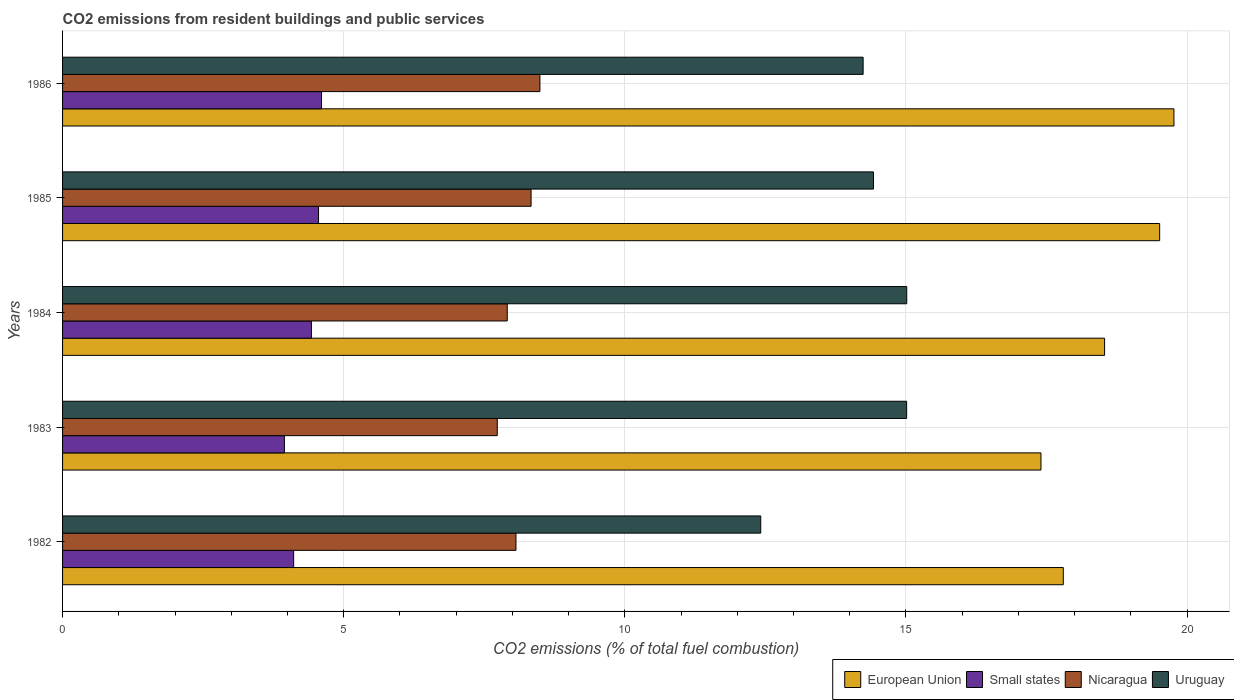How many different coloured bars are there?
Ensure brevity in your answer.  4. Are the number of bars per tick equal to the number of legend labels?
Offer a terse response. Yes. How many bars are there on the 1st tick from the bottom?
Your answer should be compact. 4. What is the total CO2 emitted in Small states in 1984?
Give a very brief answer. 4.43. Across all years, what is the maximum total CO2 emitted in Small states?
Keep it short and to the point. 4.61. Across all years, what is the minimum total CO2 emitted in Uruguay?
Keep it short and to the point. 12.42. In which year was the total CO2 emitted in Uruguay maximum?
Your response must be concise. 1984. In which year was the total CO2 emitted in Small states minimum?
Offer a terse response. 1983. What is the total total CO2 emitted in Uruguay in the graph?
Your response must be concise. 71.11. What is the difference between the total CO2 emitted in Uruguay in 1983 and that in 1984?
Offer a terse response. -0. What is the difference between the total CO2 emitted in Small states in 1985 and the total CO2 emitted in Uruguay in 1986?
Your answer should be very brief. -9.69. What is the average total CO2 emitted in Small states per year?
Your response must be concise. 4.33. In the year 1984, what is the difference between the total CO2 emitted in Small states and total CO2 emitted in European Union?
Ensure brevity in your answer.  -14.11. What is the ratio of the total CO2 emitted in Nicaragua in 1983 to that in 1986?
Provide a succinct answer. 0.91. Is the total CO2 emitted in Uruguay in 1984 less than that in 1985?
Your answer should be compact. No. Is the difference between the total CO2 emitted in Small states in 1982 and 1986 greater than the difference between the total CO2 emitted in European Union in 1982 and 1986?
Offer a very short reply. Yes. What is the difference between the highest and the second highest total CO2 emitted in Nicaragua?
Ensure brevity in your answer.  0.16. What is the difference between the highest and the lowest total CO2 emitted in European Union?
Your answer should be very brief. 2.37. Is the sum of the total CO2 emitted in Nicaragua in 1982 and 1984 greater than the maximum total CO2 emitted in Uruguay across all years?
Ensure brevity in your answer.  Yes. Is it the case that in every year, the sum of the total CO2 emitted in Nicaragua and total CO2 emitted in Uruguay is greater than the sum of total CO2 emitted in Small states and total CO2 emitted in European Union?
Offer a terse response. No. What does the 3rd bar from the top in 1986 represents?
Provide a succinct answer. Small states. What does the 2nd bar from the bottom in 1985 represents?
Your response must be concise. Small states. How many bars are there?
Your answer should be compact. 20. Does the graph contain any zero values?
Give a very brief answer. No. Where does the legend appear in the graph?
Provide a short and direct response. Bottom right. What is the title of the graph?
Ensure brevity in your answer.  CO2 emissions from resident buildings and public services. What is the label or title of the X-axis?
Keep it short and to the point. CO2 emissions (% of total fuel combustion). What is the CO2 emissions (% of total fuel combustion) of European Union in 1982?
Your response must be concise. 17.8. What is the CO2 emissions (% of total fuel combustion) of Small states in 1982?
Keep it short and to the point. 4.11. What is the CO2 emissions (% of total fuel combustion) of Nicaragua in 1982?
Provide a succinct answer. 8.06. What is the CO2 emissions (% of total fuel combustion) of Uruguay in 1982?
Offer a terse response. 12.42. What is the CO2 emissions (% of total fuel combustion) of European Union in 1983?
Your response must be concise. 17.4. What is the CO2 emissions (% of total fuel combustion) in Small states in 1983?
Offer a terse response. 3.95. What is the CO2 emissions (% of total fuel combustion) of Nicaragua in 1983?
Your answer should be very brief. 7.73. What is the CO2 emissions (% of total fuel combustion) in Uruguay in 1983?
Your answer should be very brief. 15.01. What is the CO2 emissions (% of total fuel combustion) in European Union in 1984?
Your response must be concise. 18.53. What is the CO2 emissions (% of total fuel combustion) in Small states in 1984?
Your response must be concise. 4.43. What is the CO2 emissions (% of total fuel combustion) of Nicaragua in 1984?
Ensure brevity in your answer.  7.91. What is the CO2 emissions (% of total fuel combustion) of Uruguay in 1984?
Make the answer very short. 15.02. What is the CO2 emissions (% of total fuel combustion) of European Union in 1985?
Your answer should be very brief. 19.51. What is the CO2 emissions (% of total fuel combustion) in Small states in 1985?
Your answer should be very brief. 4.55. What is the CO2 emissions (% of total fuel combustion) of Nicaragua in 1985?
Offer a very short reply. 8.33. What is the CO2 emissions (% of total fuel combustion) in Uruguay in 1985?
Your answer should be very brief. 14.42. What is the CO2 emissions (% of total fuel combustion) of European Union in 1986?
Offer a very short reply. 19.77. What is the CO2 emissions (% of total fuel combustion) in Small states in 1986?
Your answer should be very brief. 4.61. What is the CO2 emissions (% of total fuel combustion) in Nicaragua in 1986?
Provide a short and direct response. 8.49. What is the CO2 emissions (% of total fuel combustion) in Uruguay in 1986?
Provide a succinct answer. 14.24. Across all years, what is the maximum CO2 emissions (% of total fuel combustion) of European Union?
Keep it short and to the point. 19.77. Across all years, what is the maximum CO2 emissions (% of total fuel combustion) in Small states?
Give a very brief answer. 4.61. Across all years, what is the maximum CO2 emissions (% of total fuel combustion) in Nicaragua?
Offer a terse response. 8.49. Across all years, what is the maximum CO2 emissions (% of total fuel combustion) in Uruguay?
Keep it short and to the point. 15.02. Across all years, what is the minimum CO2 emissions (% of total fuel combustion) in European Union?
Offer a very short reply. 17.4. Across all years, what is the minimum CO2 emissions (% of total fuel combustion) of Small states?
Provide a succinct answer. 3.95. Across all years, what is the minimum CO2 emissions (% of total fuel combustion) in Nicaragua?
Ensure brevity in your answer.  7.73. Across all years, what is the minimum CO2 emissions (% of total fuel combustion) of Uruguay?
Offer a very short reply. 12.42. What is the total CO2 emissions (% of total fuel combustion) in European Union in the graph?
Ensure brevity in your answer.  93.02. What is the total CO2 emissions (% of total fuel combustion) of Small states in the graph?
Offer a terse response. 21.64. What is the total CO2 emissions (% of total fuel combustion) of Nicaragua in the graph?
Keep it short and to the point. 40.53. What is the total CO2 emissions (% of total fuel combustion) of Uruguay in the graph?
Your response must be concise. 71.11. What is the difference between the CO2 emissions (% of total fuel combustion) in European Union in 1982 and that in 1983?
Keep it short and to the point. 0.4. What is the difference between the CO2 emissions (% of total fuel combustion) in Small states in 1982 and that in 1983?
Offer a terse response. 0.16. What is the difference between the CO2 emissions (% of total fuel combustion) of Nicaragua in 1982 and that in 1983?
Offer a very short reply. 0.33. What is the difference between the CO2 emissions (% of total fuel combustion) in Uruguay in 1982 and that in 1983?
Give a very brief answer. -2.6. What is the difference between the CO2 emissions (% of total fuel combustion) of European Union in 1982 and that in 1984?
Give a very brief answer. -0.73. What is the difference between the CO2 emissions (% of total fuel combustion) of Small states in 1982 and that in 1984?
Make the answer very short. -0.32. What is the difference between the CO2 emissions (% of total fuel combustion) in Nicaragua in 1982 and that in 1984?
Ensure brevity in your answer.  0.15. What is the difference between the CO2 emissions (% of total fuel combustion) in Uruguay in 1982 and that in 1984?
Provide a succinct answer. -2.6. What is the difference between the CO2 emissions (% of total fuel combustion) of European Union in 1982 and that in 1985?
Offer a terse response. -1.71. What is the difference between the CO2 emissions (% of total fuel combustion) of Small states in 1982 and that in 1985?
Your answer should be compact. -0.44. What is the difference between the CO2 emissions (% of total fuel combustion) of Nicaragua in 1982 and that in 1985?
Provide a short and direct response. -0.27. What is the difference between the CO2 emissions (% of total fuel combustion) of Uruguay in 1982 and that in 1985?
Offer a terse response. -2. What is the difference between the CO2 emissions (% of total fuel combustion) in European Union in 1982 and that in 1986?
Offer a terse response. -1.97. What is the difference between the CO2 emissions (% of total fuel combustion) in Small states in 1982 and that in 1986?
Offer a terse response. -0.5. What is the difference between the CO2 emissions (% of total fuel combustion) in Nicaragua in 1982 and that in 1986?
Your answer should be compact. -0.43. What is the difference between the CO2 emissions (% of total fuel combustion) of Uruguay in 1982 and that in 1986?
Make the answer very short. -1.82. What is the difference between the CO2 emissions (% of total fuel combustion) of European Union in 1983 and that in 1984?
Ensure brevity in your answer.  -1.13. What is the difference between the CO2 emissions (% of total fuel combustion) of Small states in 1983 and that in 1984?
Offer a very short reply. -0.48. What is the difference between the CO2 emissions (% of total fuel combustion) of Nicaragua in 1983 and that in 1984?
Offer a very short reply. -0.18. What is the difference between the CO2 emissions (% of total fuel combustion) of Uruguay in 1983 and that in 1984?
Give a very brief answer. -0. What is the difference between the CO2 emissions (% of total fuel combustion) in European Union in 1983 and that in 1985?
Provide a short and direct response. -2.11. What is the difference between the CO2 emissions (% of total fuel combustion) of Small states in 1983 and that in 1985?
Provide a succinct answer. -0.61. What is the difference between the CO2 emissions (% of total fuel combustion) in Nicaragua in 1983 and that in 1985?
Keep it short and to the point. -0.6. What is the difference between the CO2 emissions (% of total fuel combustion) of Uruguay in 1983 and that in 1985?
Offer a terse response. 0.59. What is the difference between the CO2 emissions (% of total fuel combustion) in European Union in 1983 and that in 1986?
Provide a short and direct response. -2.37. What is the difference between the CO2 emissions (% of total fuel combustion) of Small states in 1983 and that in 1986?
Offer a very short reply. -0.66. What is the difference between the CO2 emissions (% of total fuel combustion) of Nicaragua in 1983 and that in 1986?
Your answer should be compact. -0.76. What is the difference between the CO2 emissions (% of total fuel combustion) of Uruguay in 1983 and that in 1986?
Provide a short and direct response. 0.77. What is the difference between the CO2 emissions (% of total fuel combustion) of European Union in 1984 and that in 1985?
Your answer should be very brief. -0.98. What is the difference between the CO2 emissions (% of total fuel combustion) of Small states in 1984 and that in 1985?
Offer a very short reply. -0.13. What is the difference between the CO2 emissions (% of total fuel combustion) of Nicaragua in 1984 and that in 1985?
Your answer should be very brief. -0.42. What is the difference between the CO2 emissions (% of total fuel combustion) of Uruguay in 1984 and that in 1985?
Provide a succinct answer. 0.59. What is the difference between the CO2 emissions (% of total fuel combustion) in European Union in 1984 and that in 1986?
Your response must be concise. -1.23. What is the difference between the CO2 emissions (% of total fuel combustion) of Small states in 1984 and that in 1986?
Provide a succinct answer. -0.18. What is the difference between the CO2 emissions (% of total fuel combustion) in Nicaragua in 1984 and that in 1986?
Provide a short and direct response. -0.58. What is the difference between the CO2 emissions (% of total fuel combustion) in Uruguay in 1984 and that in 1986?
Your answer should be very brief. 0.78. What is the difference between the CO2 emissions (% of total fuel combustion) of European Union in 1985 and that in 1986?
Your answer should be very brief. -0.25. What is the difference between the CO2 emissions (% of total fuel combustion) of Small states in 1985 and that in 1986?
Give a very brief answer. -0.05. What is the difference between the CO2 emissions (% of total fuel combustion) in Nicaragua in 1985 and that in 1986?
Keep it short and to the point. -0.16. What is the difference between the CO2 emissions (% of total fuel combustion) in Uruguay in 1985 and that in 1986?
Your answer should be very brief. 0.18. What is the difference between the CO2 emissions (% of total fuel combustion) of European Union in 1982 and the CO2 emissions (% of total fuel combustion) of Small states in 1983?
Offer a terse response. 13.85. What is the difference between the CO2 emissions (% of total fuel combustion) of European Union in 1982 and the CO2 emissions (% of total fuel combustion) of Nicaragua in 1983?
Make the answer very short. 10.07. What is the difference between the CO2 emissions (% of total fuel combustion) of European Union in 1982 and the CO2 emissions (% of total fuel combustion) of Uruguay in 1983?
Your answer should be compact. 2.79. What is the difference between the CO2 emissions (% of total fuel combustion) of Small states in 1982 and the CO2 emissions (% of total fuel combustion) of Nicaragua in 1983?
Give a very brief answer. -3.62. What is the difference between the CO2 emissions (% of total fuel combustion) in Small states in 1982 and the CO2 emissions (% of total fuel combustion) in Uruguay in 1983?
Make the answer very short. -10.9. What is the difference between the CO2 emissions (% of total fuel combustion) of Nicaragua in 1982 and the CO2 emissions (% of total fuel combustion) of Uruguay in 1983?
Give a very brief answer. -6.95. What is the difference between the CO2 emissions (% of total fuel combustion) in European Union in 1982 and the CO2 emissions (% of total fuel combustion) in Small states in 1984?
Provide a succinct answer. 13.37. What is the difference between the CO2 emissions (% of total fuel combustion) in European Union in 1982 and the CO2 emissions (% of total fuel combustion) in Nicaragua in 1984?
Make the answer very short. 9.89. What is the difference between the CO2 emissions (% of total fuel combustion) of European Union in 1982 and the CO2 emissions (% of total fuel combustion) of Uruguay in 1984?
Keep it short and to the point. 2.78. What is the difference between the CO2 emissions (% of total fuel combustion) in Small states in 1982 and the CO2 emissions (% of total fuel combustion) in Nicaragua in 1984?
Provide a succinct answer. -3.8. What is the difference between the CO2 emissions (% of total fuel combustion) of Small states in 1982 and the CO2 emissions (% of total fuel combustion) of Uruguay in 1984?
Your response must be concise. -10.9. What is the difference between the CO2 emissions (% of total fuel combustion) in Nicaragua in 1982 and the CO2 emissions (% of total fuel combustion) in Uruguay in 1984?
Make the answer very short. -6.95. What is the difference between the CO2 emissions (% of total fuel combustion) of European Union in 1982 and the CO2 emissions (% of total fuel combustion) of Small states in 1985?
Offer a terse response. 13.25. What is the difference between the CO2 emissions (% of total fuel combustion) in European Union in 1982 and the CO2 emissions (% of total fuel combustion) in Nicaragua in 1985?
Make the answer very short. 9.47. What is the difference between the CO2 emissions (% of total fuel combustion) in European Union in 1982 and the CO2 emissions (% of total fuel combustion) in Uruguay in 1985?
Offer a very short reply. 3.38. What is the difference between the CO2 emissions (% of total fuel combustion) of Small states in 1982 and the CO2 emissions (% of total fuel combustion) of Nicaragua in 1985?
Ensure brevity in your answer.  -4.22. What is the difference between the CO2 emissions (% of total fuel combustion) of Small states in 1982 and the CO2 emissions (% of total fuel combustion) of Uruguay in 1985?
Offer a very short reply. -10.31. What is the difference between the CO2 emissions (% of total fuel combustion) of Nicaragua in 1982 and the CO2 emissions (% of total fuel combustion) of Uruguay in 1985?
Your response must be concise. -6.36. What is the difference between the CO2 emissions (% of total fuel combustion) in European Union in 1982 and the CO2 emissions (% of total fuel combustion) in Small states in 1986?
Keep it short and to the point. 13.19. What is the difference between the CO2 emissions (% of total fuel combustion) of European Union in 1982 and the CO2 emissions (% of total fuel combustion) of Nicaragua in 1986?
Offer a very short reply. 9.31. What is the difference between the CO2 emissions (% of total fuel combustion) of European Union in 1982 and the CO2 emissions (% of total fuel combustion) of Uruguay in 1986?
Your answer should be compact. 3.56. What is the difference between the CO2 emissions (% of total fuel combustion) of Small states in 1982 and the CO2 emissions (% of total fuel combustion) of Nicaragua in 1986?
Keep it short and to the point. -4.38. What is the difference between the CO2 emissions (% of total fuel combustion) in Small states in 1982 and the CO2 emissions (% of total fuel combustion) in Uruguay in 1986?
Provide a short and direct response. -10.13. What is the difference between the CO2 emissions (% of total fuel combustion) in Nicaragua in 1982 and the CO2 emissions (% of total fuel combustion) in Uruguay in 1986?
Provide a short and direct response. -6.17. What is the difference between the CO2 emissions (% of total fuel combustion) in European Union in 1983 and the CO2 emissions (% of total fuel combustion) in Small states in 1984?
Give a very brief answer. 12.98. What is the difference between the CO2 emissions (% of total fuel combustion) in European Union in 1983 and the CO2 emissions (% of total fuel combustion) in Nicaragua in 1984?
Provide a short and direct response. 9.49. What is the difference between the CO2 emissions (% of total fuel combustion) in European Union in 1983 and the CO2 emissions (% of total fuel combustion) in Uruguay in 1984?
Make the answer very short. 2.39. What is the difference between the CO2 emissions (% of total fuel combustion) in Small states in 1983 and the CO2 emissions (% of total fuel combustion) in Nicaragua in 1984?
Your answer should be very brief. -3.96. What is the difference between the CO2 emissions (% of total fuel combustion) in Small states in 1983 and the CO2 emissions (% of total fuel combustion) in Uruguay in 1984?
Your answer should be very brief. -11.07. What is the difference between the CO2 emissions (% of total fuel combustion) of Nicaragua in 1983 and the CO2 emissions (% of total fuel combustion) of Uruguay in 1984?
Ensure brevity in your answer.  -7.28. What is the difference between the CO2 emissions (% of total fuel combustion) in European Union in 1983 and the CO2 emissions (% of total fuel combustion) in Small states in 1985?
Keep it short and to the point. 12.85. What is the difference between the CO2 emissions (% of total fuel combustion) of European Union in 1983 and the CO2 emissions (% of total fuel combustion) of Nicaragua in 1985?
Ensure brevity in your answer.  9.07. What is the difference between the CO2 emissions (% of total fuel combustion) in European Union in 1983 and the CO2 emissions (% of total fuel combustion) in Uruguay in 1985?
Keep it short and to the point. 2.98. What is the difference between the CO2 emissions (% of total fuel combustion) of Small states in 1983 and the CO2 emissions (% of total fuel combustion) of Nicaragua in 1985?
Provide a short and direct response. -4.39. What is the difference between the CO2 emissions (% of total fuel combustion) of Small states in 1983 and the CO2 emissions (% of total fuel combustion) of Uruguay in 1985?
Ensure brevity in your answer.  -10.48. What is the difference between the CO2 emissions (% of total fuel combustion) in Nicaragua in 1983 and the CO2 emissions (% of total fuel combustion) in Uruguay in 1985?
Offer a very short reply. -6.69. What is the difference between the CO2 emissions (% of total fuel combustion) of European Union in 1983 and the CO2 emissions (% of total fuel combustion) of Small states in 1986?
Provide a succinct answer. 12.8. What is the difference between the CO2 emissions (% of total fuel combustion) of European Union in 1983 and the CO2 emissions (% of total fuel combustion) of Nicaragua in 1986?
Offer a terse response. 8.91. What is the difference between the CO2 emissions (% of total fuel combustion) of European Union in 1983 and the CO2 emissions (% of total fuel combustion) of Uruguay in 1986?
Offer a terse response. 3.16. What is the difference between the CO2 emissions (% of total fuel combustion) of Small states in 1983 and the CO2 emissions (% of total fuel combustion) of Nicaragua in 1986?
Ensure brevity in your answer.  -4.54. What is the difference between the CO2 emissions (% of total fuel combustion) in Small states in 1983 and the CO2 emissions (% of total fuel combustion) in Uruguay in 1986?
Offer a very short reply. -10.29. What is the difference between the CO2 emissions (% of total fuel combustion) in Nicaragua in 1983 and the CO2 emissions (% of total fuel combustion) in Uruguay in 1986?
Provide a succinct answer. -6.51. What is the difference between the CO2 emissions (% of total fuel combustion) of European Union in 1984 and the CO2 emissions (% of total fuel combustion) of Small states in 1985?
Your answer should be compact. 13.98. What is the difference between the CO2 emissions (% of total fuel combustion) of European Union in 1984 and the CO2 emissions (% of total fuel combustion) of Nicaragua in 1985?
Ensure brevity in your answer.  10.2. What is the difference between the CO2 emissions (% of total fuel combustion) of European Union in 1984 and the CO2 emissions (% of total fuel combustion) of Uruguay in 1985?
Keep it short and to the point. 4.11. What is the difference between the CO2 emissions (% of total fuel combustion) in Small states in 1984 and the CO2 emissions (% of total fuel combustion) in Nicaragua in 1985?
Ensure brevity in your answer.  -3.91. What is the difference between the CO2 emissions (% of total fuel combustion) in Small states in 1984 and the CO2 emissions (% of total fuel combustion) in Uruguay in 1985?
Provide a short and direct response. -10. What is the difference between the CO2 emissions (% of total fuel combustion) in Nicaragua in 1984 and the CO2 emissions (% of total fuel combustion) in Uruguay in 1985?
Make the answer very short. -6.51. What is the difference between the CO2 emissions (% of total fuel combustion) of European Union in 1984 and the CO2 emissions (% of total fuel combustion) of Small states in 1986?
Your response must be concise. 13.93. What is the difference between the CO2 emissions (% of total fuel combustion) in European Union in 1984 and the CO2 emissions (% of total fuel combustion) in Nicaragua in 1986?
Keep it short and to the point. 10.04. What is the difference between the CO2 emissions (% of total fuel combustion) of European Union in 1984 and the CO2 emissions (% of total fuel combustion) of Uruguay in 1986?
Your response must be concise. 4.29. What is the difference between the CO2 emissions (% of total fuel combustion) of Small states in 1984 and the CO2 emissions (% of total fuel combustion) of Nicaragua in 1986?
Offer a very short reply. -4.06. What is the difference between the CO2 emissions (% of total fuel combustion) in Small states in 1984 and the CO2 emissions (% of total fuel combustion) in Uruguay in 1986?
Your response must be concise. -9.81. What is the difference between the CO2 emissions (% of total fuel combustion) in Nicaragua in 1984 and the CO2 emissions (% of total fuel combustion) in Uruguay in 1986?
Provide a succinct answer. -6.33. What is the difference between the CO2 emissions (% of total fuel combustion) of European Union in 1985 and the CO2 emissions (% of total fuel combustion) of Small states in 1986?
Make the answer very short. 14.91. What is the difference between the CO2 emissions (% of total fuel combustion) in European Union in 1985 and the CO2 emissions (% of total fuel combustion) in Nicaragua in 1986?
Give a very brief answer. 11.02. What is the difference between the CO2 emissions (% of total fuel combustion) of European Union in 1985 and the CO2 emissions (% of total fuel combustion) of Uruguay in 1986?
Your answer should be compact. 5.27. What is the difference between the CO2 emissions (% of total fuel combustion) in Small states in 1985 and the CO2 emissions (% of total fuel combustion) in Nicaragua in 1986?
Your response must be concise. -3.94. What is the difference between the CO2 emissions (% of total fuel combustion) of Small states in 1985 and the CO2 emissions (% of total fuel combustion) of Uruguay in 1986?
Provide a succinct answer. -9.69. What is the difference between the CO2 emissions (% of total fuel combustion) of Nicaragua in 1985 and the CO2 emissions (% of total fuel combustion) of Uruguay in 1986?
Your answer should be compact. -5.91. What is the average CO2 emissions (% of total fuel combustion) of European Union per year?
Provide a short and direct response. 18.6. What is the average CO2 emissions (% of total fuel combustion) of Small states per year?
Offer a terse response. 4.33. What is the average CO2 emissions (% of total fuel combustion) of Nicaragua per year?
Your answer should be very brief. 8.11. What is the average CO2 emissions (% of total fuel combustion) of Uruguay per year?
Your answer should be very brief. 14.22. In the year 1982, what is the difference between the CO2 emissions (% of total fuel combustion) of European Union and CO2 emissions (% of total fuel combustion) of Small states?
Your answer should be very brief. 13.69. In the year 1982, what is the difference between the CO2 emissions (% of total fuel combustion) of European Union and CO2 emissions (% of total fuel combustion) of Nicaragua?
Your response must be concise. 9.74. In the year 1982, what is the difference between the CO2 emissions (% of total fuel combustion) of European Union and CO2 emissions (% of total fuel combustion) of Uruguay?
Give a very brief answer. 5.38. In the year 1982, what is the difference between the CO2 emissions (% of total fuel combustion) of Small states and CO2 emissions (% of total fuel combustion) of Nicaragua?
Make the answer very short. -3.95. In the year 1982, what is the difference between the CO2 emissions (% of total fuel combustion) in Small states and CO2 emissions (% of total fuel combustion) in Uruguay?
Ensure brevity in your answer.  -8.31. In the year 1982, what is the difference between the CO2 emissions (% of total fuel combustion) of Nicaragua and CO2 emissions (% of total fuel combustion) of Uruguay?
Give a very brief answer. -4.35. In the year 1983, what is the difference between the CO2 emissions (% of total fuel combustion) in European Union and CO2 emissions (% of total fuel combustion) in Small states?
Ensure brevity in your answer.  13.46. In the year 1983, what is the difference between the CO2 emissions (% of total fuel combustion) in European Union and CO2 emissions (% of total fuel combustion) in Nicaragua?
Your answer should be very brief. 9.67. In the year 1983, what is the difference between the CO2 emissions (% of total fuel combustion) in European Union and CO2 emissions (% of total fuel combustion) in Uruguay?
Ensure brevity in your answer.  2.39. In the year 1983, what is the difference between the CO2 emissions (% of total fuel combustion) of Small states and CO2 emissions (% of total fuel combustion) of Nicaragua?
Offer a very short reply. -3.79. In the year 1983, what is the difference between the CO2 emissions (% of total fuel combustion) of Small states and CO2 emissions (% of total fuel combustion) of Uruguay?
Give a very brief answer. -11.07. In the year 1983, what is the difference between the CO2 emissions (% of total fuel combustion) of Nicaragua and CO2 emissions (% of total fuel combustion) of Uruguay?
Provide a short and direct response. -7.28. In the year 1984, what is the difference between the CO2 emissions (% of total fuel combustion) of European Union and CO2 emissions (% of total fuel combustion) of Small states?
Keep it short and to the point. 14.11. In the year 1984, what is the difference between the CO2 emissions (% of total fuel combustion) of European Union and CO2 emissions (% of total fuel combustion) of Nicaragua?
Your answer should be compact. 10.62. In the year 1984, what is the difference between the CO2 emissions (% of total fuel combustion) of European Union and CO2 emissions (% of total fuel combustion) of Uruguay?
Give a very brief answer. 3.52. In the year 1984, what is the difference between the CO2 emissions (% of total fuel combustion) of Small states and CO2 emissions (% of total fuel combustion) of Nicaragua?
Offer a very short reply. -3.48. In the year 1984, what is the difference between the CO2 emissions (% of total fuel combustion) of Small states and CO2 emissions (% of total fuel combustion) of Uruguay?
Keep it short and to the point. -10.59. In the year 1984, what is the difference between the CO2 emissions (% of total fuel combustion) in Nicaragua and CO2 emissions (% of total fuel combustion) in Uruguay?
Your answer should be compact. -7.11. In the year 1985, what is the difference between the CO2 emissions (% of total fuel combustion) in European Union and CO2 emissions (% of total fuel combustion) in Small states?
Provide a short and direct response. 14.96. In the year 1985, what is the difference between the CO2 emissions (% of total fuel combustion) of European Union and CO2 emissions (% of total fuel combustion) of Nicaragua?
Provide a short and direct response. 11.18. In the year 1985, what is the difference between the CO2 emissions (% of total fuel combustion) of European Union and CO2 emissions (% of total fuel combustion) of Uruguay?
Your response must be concise. 5.09. In the year 1985, what is the difference between the CO2 emissions (% of total fuel combustion) in Small states and CO2 emissions (% of total fuel combustion) in Nicaragua?
Give a very brief answer. -3.78. In the year 1985, what is the difference between the CO2 emissions (% of total fuel combustion) in Small states and CO2 emissions (% of total fuel combustion) in Uruguay?
Provide a short and direct response. -9.87. In the year 1985, what is the difference between the CO2 emissions (% of total fuel combustion) of Nicaragua and CO2 emissions (% of total fuel combustion) of Uruguay?
Your answer should be compact. -6.09. In the year 1986, what is the difference between the CO2 emissions (% of total fuel combustion) in European Union and CO2 emissions (% of total fuel combustion) in Small states?
Ensure brevity in your answer.  15.16. In the year 1986, what is the difference between the CO2 emissions (% of total fuel combustion) in European Union and CO2 emissions (% of total fuel combustion) in Nicaragua?
Provide a short and direct response. 11.28. In the year 1986, what is the difference between the CO2 emissions (% of total fuel combustion) of European Union and CO2 emissions (% of total fuel combustion) of Uruguay?
Offer a terse response. 5.53. In the year 1986, what is the difference between the CO2 emissions (% of total fuel combustion) in Small states and CO2 emissions (% of total fuel combustion) in Nicaragua?
Your answer should be compact. -3.88. In the year 1986, what is the difference between the CO2 emissions (% of total fuel combustion) of Small states and CO2 emissions (% of total fuel combustion) of Uruguay?
Offer a terse response. -9.63. In the year 1986, what is the difference between the CO2 emissions (% of total fuel combustion) of Nicaragua and CO2 emissions (% of total fuel combustion) of Uruguay?
Your response must be concise. -5.75. What is the ratio of the CO2 emissions (% of total fuel combustion) in European Union in 1982 to that in 1983?
Offer a very short reply. 1.02. What is the ratio of the CO2 emissions (% of total fuel combustion) of Small states in 1982 to that in 1983?
Ensure brevity in your answer.  1.04. What is the ratio of the CO2 emissions (% of total fuel combustion) in Nicaragua in 1982 to that in 1983?
Ensure brevity in your answer.  1.04. What is the ratio of the CO2 emissions (% of total fuel combustion) in Uruguay in 1982 to that in 1983?
Your answer should be compact. 0.83. What is the ratio of the CO2 emissions (% of total fuel combustion) of European Union in 1982 to that in 1984?
Keep it short and to the point. 0.96. What is the ratio of the CO2 emissions (% of total fuel combustion) of Small states in 1982 to that in 1984?
Give a very brief answer. 0.93. What is the ratio of the CO2 emissions (% of total fuel combustion) in Nicaragua in 1982 to that in 1984?
Your answer should be compact. 1.02. What is the ratio of the CO2 emissions (% of total fuel combustion) of Uruguay in 1982 to that in 1984?
Provide a succinct answer. 0.83. What is the ratio of the CO2 emissions (% of total fuel combustion) of European Union in 1982 to that in 1985?
Provide a succinct answer. 0.91. What is the ratio of the CO2 emissions (% of total fuel combustion) of Small states in 1982 to that in 1985?
Make the answer very short. 0.9. What is the ratio of the CO2 emissions (% of total fuel combustion) of Nicaragua in 1982 to that in 1985?
Offer a terse response. 0.97. What is the ratio of the CO2 emissions (% of total fuel combustion) of Uruguay in 1982 to that in 1985?
Provide a short and direct response. 0.86. What is the ratio of the CO2 emissions (% of total fuel combustion) in European Union in 1982 to that in 1986?
Give a very brief answer. 0.9. What is the ratio of the CO2 emissions (% of total fuel combustion) of Small states in 1982 to that in 1986?
Your response must be concise. 0.89. What is the ratio of the CO2 emissions (% of total fuel combustion) of Nicaragua in 1982 to that in 1986?
Your answer should be very brief. 0.95. What is the ratio of the CO2 emissions (% of total fuel combustion) in Uruguay in 1982 to that in 1986?
Provide a succinct answer. 0.87. What is the ratio of the CO2 emissions (% of total fuel combustion) in European Union in 1983 to that in 1984?
Your response must be concise. 0.94. What is the ratio of the CO2 emissions (% of total fuel combustion) of Small states in 1983 to that in 1984?
Your answer should be compact. 0.89. What is the ratio of the CO2 emissions (% of total fuel combustion) in Nicaragua in 1983 to that in 1984?
Make the answer very short. 0.98. What is the ratio of the CO2 emissions (% of total fuel combustion) of European Union in 1983 to that in 1985?
Offer a very short reply. 0.89. What is the ratio of the CO2 emissions (% of total fuel combustion) of Small states in 1983 to that in 1985?
Provide a succinct answer. 0.87. What is the ratio of the CO2 emissions (% of total fuel combustion) of Nicaragua in 1983 to that in 1985?
Offer a very short reply. 0.93. What is the ratio of the CO2 emissions (% of total fuel combustion) in Uruguay in 1983 to that in 1985?
Provide a short and direct response. 1.04. What is the ratio of the CO2 emissions (% of total fuel combustion) of European Union in 1983 to that in 1986?
Your response must be concise. 0.88. What is the ratio of the CO2 emissions (% of total fuel combustion) in Small states in 1983 to that in 1986?
Your answer should be very brief. 0.86. What is the ratio of the CO2 emissions (% of total fuel combustion) in Nicaragua in 1983 to that in 1986?
Make the answer very short. 0.91. What is the ratio of the CO2 emissions (% of total fuel combustion) of Uruguay in 1983 to that in 1986?
Provide a succinct answer. 1.05. What is the ratio of the CO2 emissions (% of total fuel combustion) in European Union in 1984 to that in 1985?
Provide a succinct answer. 0.95. What is the ratio of the CO2 emissions (% of total fuel combustion) in Small states in 1984 to that in 1985?
Offer a terse response. 0.97. What is the ratio of the CO2 emissions (% of total fuel combustion) in Nicaragua in 1984 to that in 1985?
Make the answer very short. 0.95. What is the ratio of the CO2 emissions (% of total fuel combustion) in Uruguay in 1984 to that in 1985?
Your response must be concise. 1.04. What is the ratio of the CO2 emissions (% of total fuel combustion) of European Union in 1984 to that in 1986?
Provide a short and direct response. 0.94. What is the ratio of the CO2 emissions (% of total fuel combustion) of Small states in 1984 to that in 1986?
Offer a terse response. 0.96. What is the ratio of the CO2 emissions (% of total fuel combustion) in Nicaragua in 1984 to that in 1986?
Provide a short and direct response. 0.93. What is the ratio of the CO2 emissions (% of total fuel combustion) of Uruguay in 1984 to that in 1986?
Provide a succinct answer. 1.05. What is the ratio of the CO2 emissions (% of total fuel combustion) of European Union in 1985 to that in 1986?
Offer a terse response. 0.99. What is the ratio of the CO2 emissions (% of total fuel combustion) in Small states in 1985 to that in 1986?
Your answer should be very brief. 0.99. What is the ratio of the CO2 emissions (% of total fuel combustion) in Nicaragua in 1985 to that in 1986?
Your response must be concise. 0.98. What is the ratio of the CO2 emissions (% of total fuel combustion) in Uruguay in 1985 to that in 1986?
Keep it short and to the point. 1.01. What is the difference between the highest and the second highest CO2 emissions (% of total fuel combustion) in European Union?
Make the answer very short. 0.25. What is the difference between the highest and the second highest CO2 emissions (% of total fuel combustion) of Small states?
Provide a short and direct response. 0.05. What is the difference between the highest and the second highest CO2 emissions (% of total fuel combustion) in Nicaragua?
Your response must be concise. 0.16. What is the difference between the highest and the second highest CO2 emissions (% of total fuel combustion) of Uruguay?
Make the answer very short. 0. What is the difference between the highest and the lowest CO2 emissions (% of total fuel combustion) of European Union?
Give a very brief answer. 2.37. What is the difference between the highest and the lowest CO2 emissions (% of total fuel combustion) of Small states?
Keep it short and to the point. 0.66. What is the difference between the highest and the lowest CO2 emissions (% of total fuel combustion) of Nicaragua?
Keep it short and to the point. 0.76. What is the difference between the highest and the lowest CO2 emissions (% of total fuel combustion) of Uruguay?
Your answer should be compact. 2.6. 